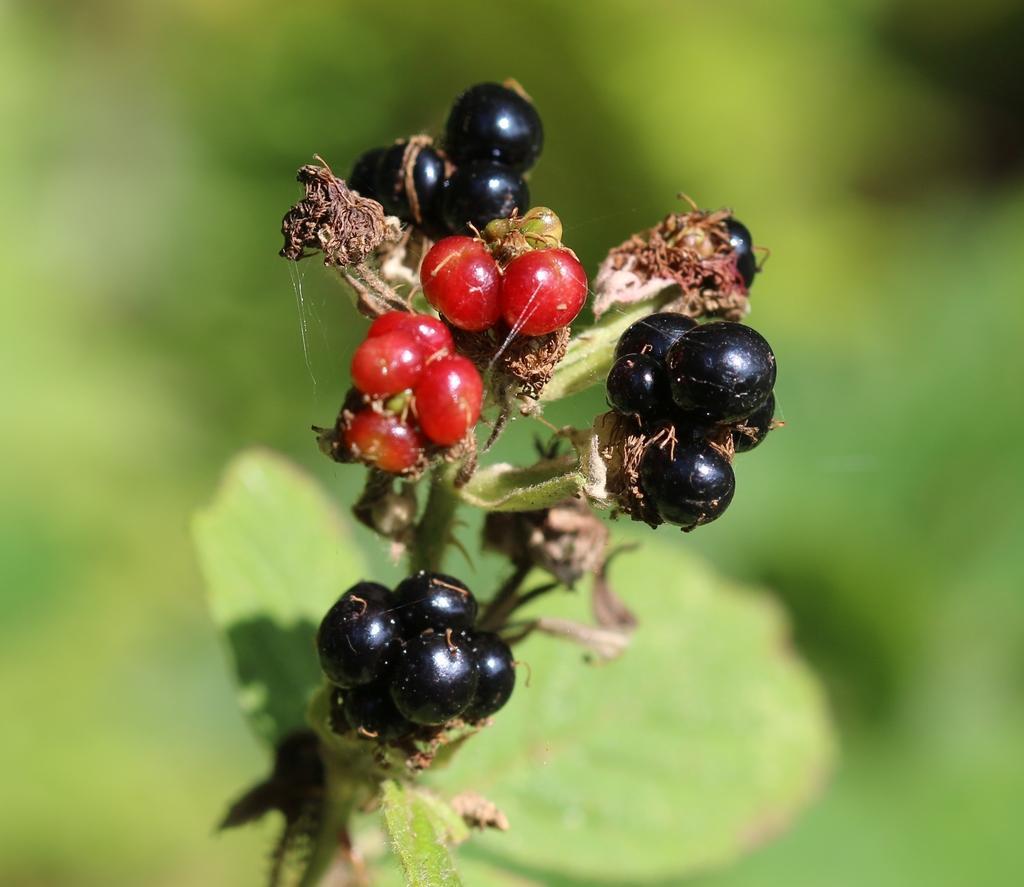How would you summarize this image in a sentence or two? In this image there are few berries in a plant. The background is blurry. The berries are black and red in color. 